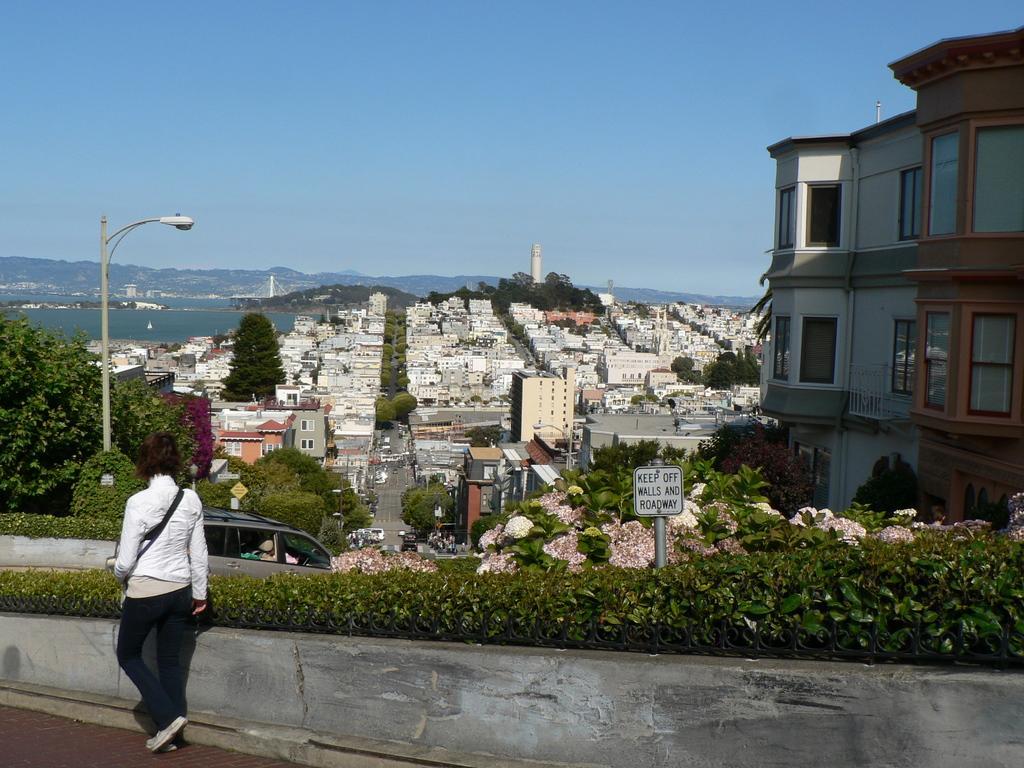Describe this image in one or two sentences. In this image we can see a person walking on the road. Here we can see walls, plants, poles, boards, vehicles, road, flowers, trees, water, towers, and buildings. In the background we can see mountain and sky. 